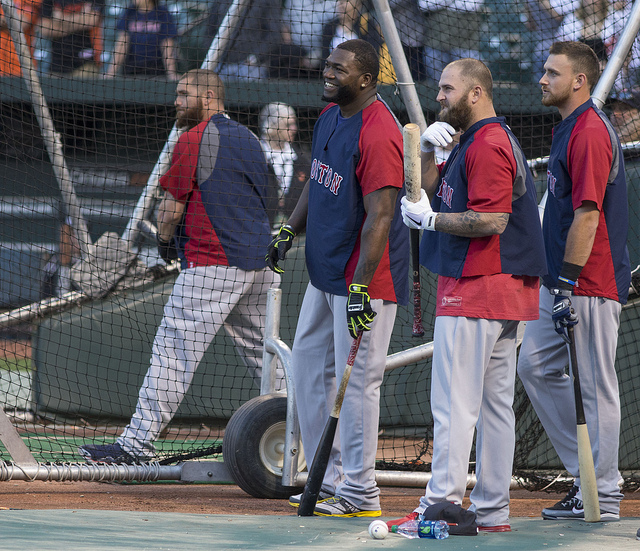Extract all visible text content from this image. 01TON 